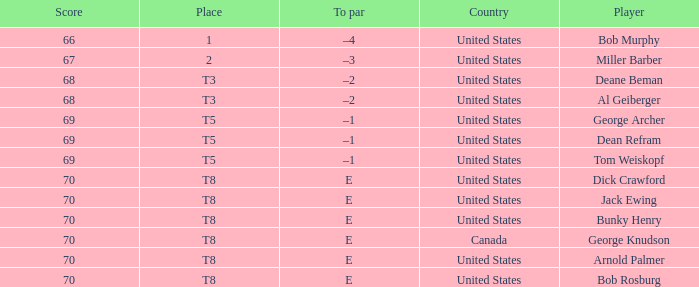Where did Bob Murphy of the United States place? 1.0. 